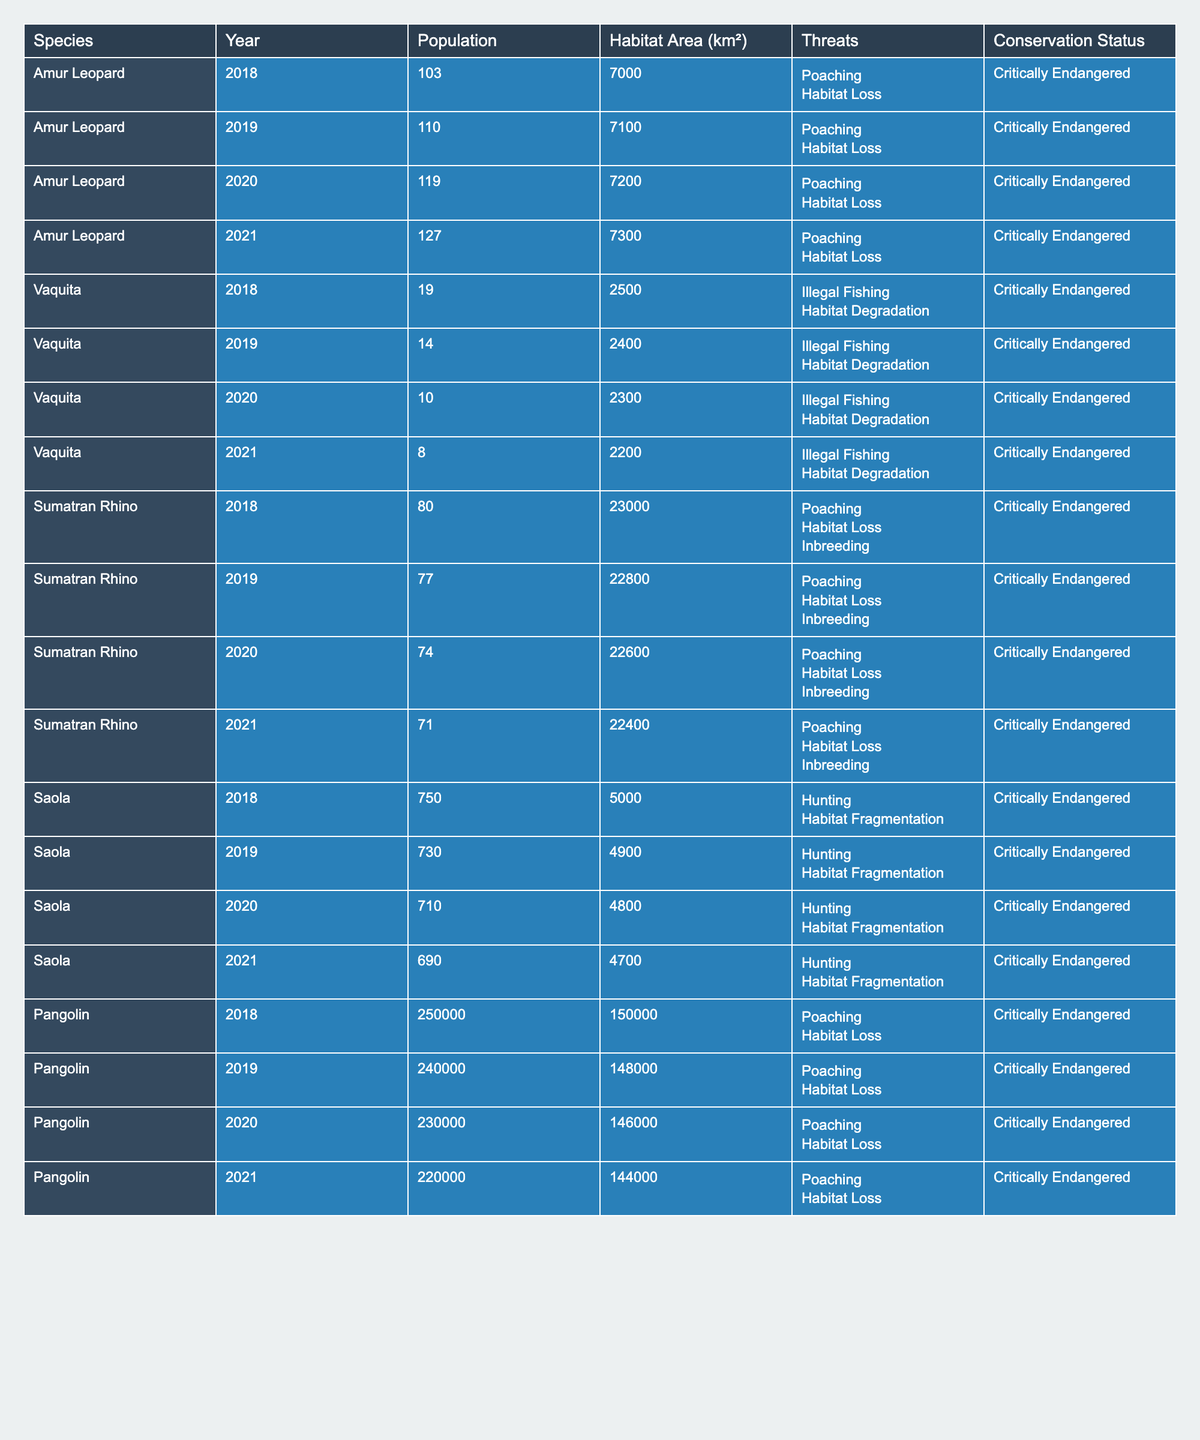What was the population of the Vaquita in 2020? The population of the Vaquita in 2020 is listed as 10 in the table.
Answer: 10 What is the conservation status of the Amur Leopard? The table indicates that the conservation status of the Amur Leopard is "Critically Endangered."
Answer: Critically Endangered What was the change in population of the Sumatran Rhino from 2018 to 2021? The population of the Sumatran Rhino decreased from 80 in 2018 to 71 in 2021. The change is calculated as 71 - 80 = -9.
Answer: -9 What are the main threats to the Saola? The main threats to the Saola, according to the table, are "Hunting" and "Habitat Fragmentation."
Answer: Hunting; Habitat Fragmentation What was the average population of the Pangolin from 2018 to 2021? To find the average, sum the populations from each year: 250000 + 240000 + 230000 + 220000 = 940000. Then divide by 4 (the number of years) to get an average of 940000 / 4 = 235000.
Answer: 235000 Is the habitat area for the populations of the Sumatran Rhino increasing over the years? The habitat area for the Sumatran Rhino decreased from 23000 km² in 2018 to 22400 km² in 2021, indicating that it is not increasing.
Answer: No Which species had the largest population recorded in the given years? The Pangolin had the largest recorded population in 2018 at 250000, according to the table.
Answer: 250000 What was the percentage decrease in the Vaquita population from 2018 to 2021? The population decreased from 19 in 2018 to 8 in 2021. The decrease is 19 - 8 = 11. The percentage decrease is (11 / 19) * 100 = 57.89%.
Answer: 57.89% How many species listed are Critically Endangered? All species listed in the table have a conservation status of "Critically Endangered," totaling five species.
Answer: 5 What trends can be observed in the population of the Saola from 2018 to 2021? The population of the Saola shows a declining trend, from 750 in 2018 to 690 in 2021. This indicates a steady decrease each year.
Answer: Declining trend 